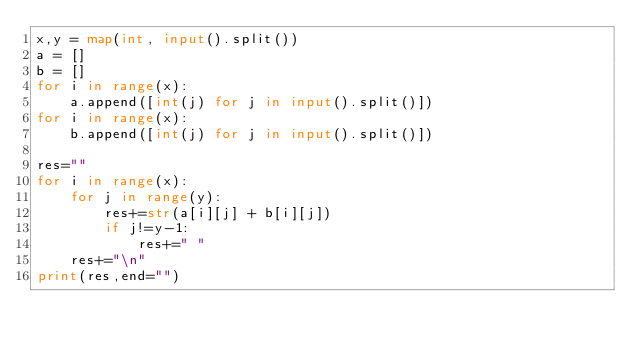<code> <loc_0><loc_0><loc_500><loc_500><_Python_>x,y = map(int, input().split())
a = []
b = []
for i in range(x):
    a.append([int(j) for j in input().split()])
for i in range(x):
    b.append([int(j) for j in input().split()])

res=""
for i in range(x):
    for j in range(y):
        res+=str(a[i][j] + b[i][j])
        if j!=y-1:
            res+=" "
    res+="\n"
print(res,end="")
</code> 